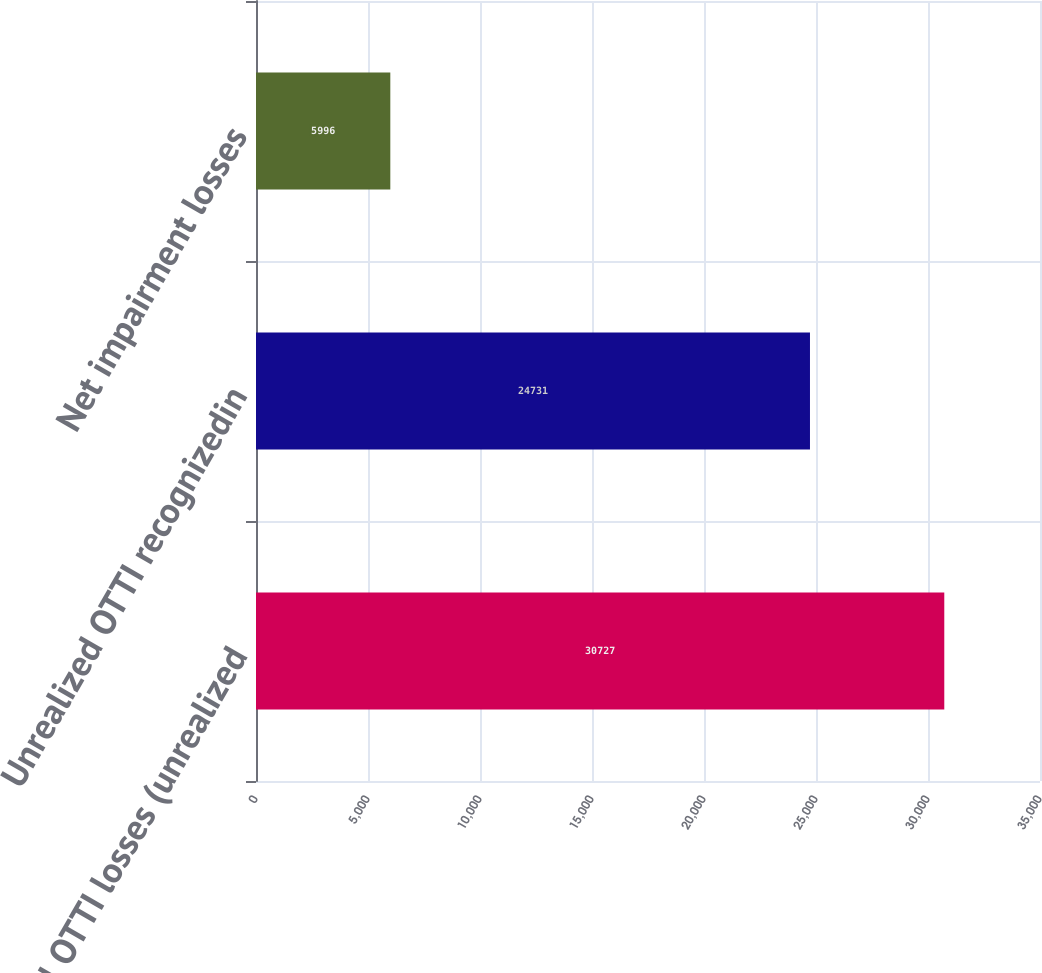Convert chart. <chart><loc_0><loc_0><loc_500><loc_500><bar_chart><fcel>Total OTTI losses (unrealized<fcel>Unrealized OTTI recognizedin<fcel>Net impairment losses<nl><fcel>30727<fcel>24731<fcel>5996<nl></chart> 